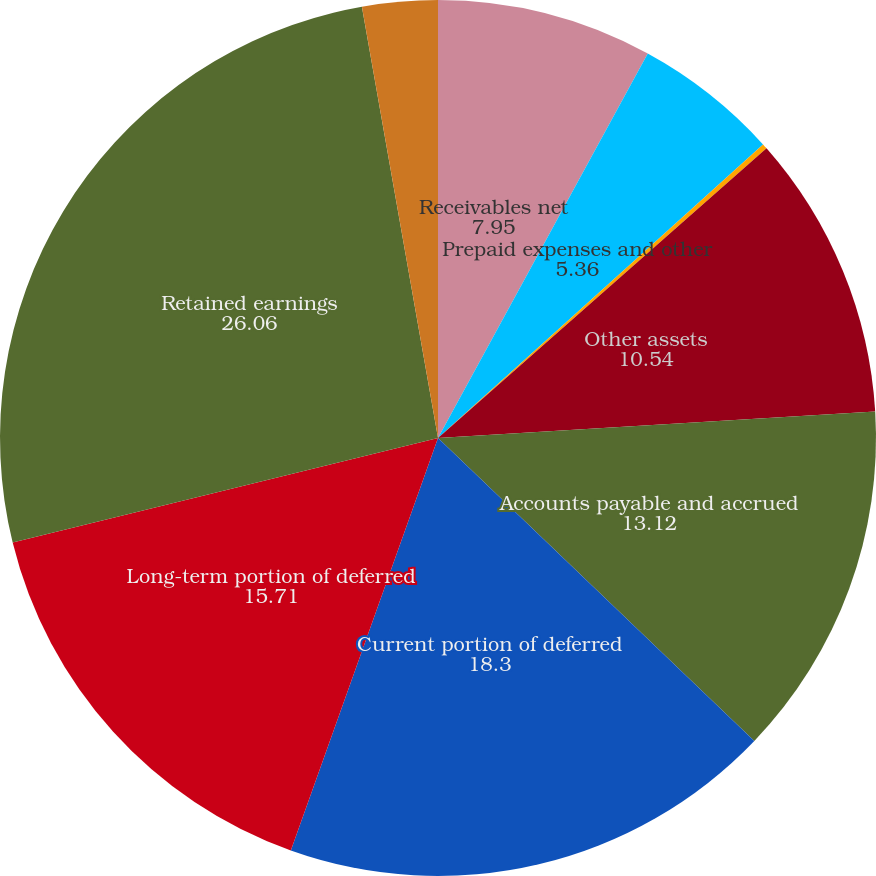Convert chart to OTSL. <chart><loc_0><loc_0><loc_500><loc_500><pie_chart><fcel>Receivables net<fcel>Prepaid expenses and other<fcel>Long-term receivables<fcel>Other assets<fcel>Accounts payable and accrued<fcel>Current portion of deferred<fcel>Long-term portion of deferred<fcel>Retained earnings<fcel>Accumulated other<nl><fcel>7.95%<fcel>5.36%<fcel>0.19%<fcel>10.54%<fcel>13.12%<fcel>18.3%<fcel>15.71%<fcel>26.06%<fcel>2.78%<nl></chart> 